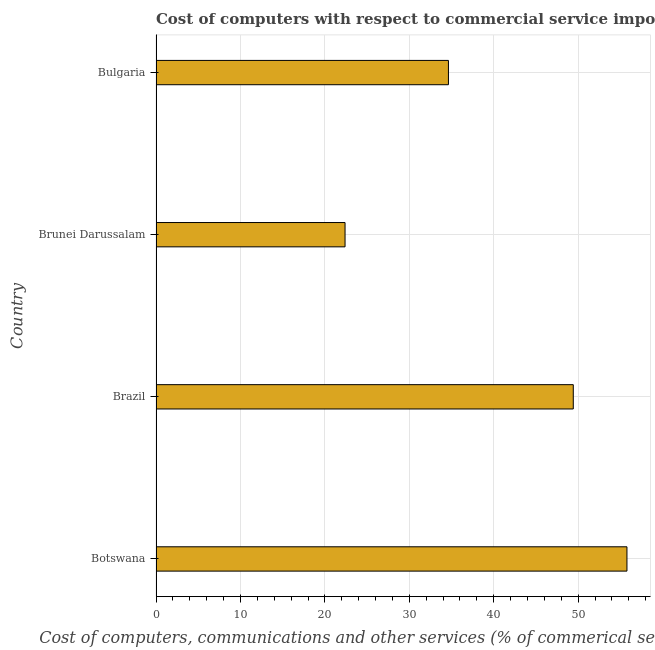Does the graph contain any zero values?
Provide a succinct answer. No. Does the graph contain grids?
Keep it short and to the point. Yes. What is the title of the graph?
Offer a terse response. Cost of computers with respect to commercial service imports of countries in 2009. What is the label or title of the X-axis?
Provide a succinct answer. Cost of computers, communications and other services (% of commerical service exports). What is the cost of communications in Brunei Darussalam?
Your answer should be compact. 22.39. Across all countries, what is the maximum cost of communications?
Keep it short and to the point. 55.78. Across all countries, what is the minimum  computer and other services?
Provide a succinct answer. 22.39. In which country was the cost of communications maximum?
Your response must be concise. Botswana. In which country was the  computer and other services minimum?
Provide a succinct answer. Brunei Darussalam. What is the sum of the cost of communications?
Offer a terse response. 162.22. What is the difference between the cost of communications in Brunei Darussalam and Bulgaria?
Give a very brief answer. -12.25. What is the average  computer and other services per country?
Your answer should be very brief. 40.55. What is the median  computer and other services?
Give a very brief answer. 42.03. What is the ratio of the cost of communications in Botswana to that in Brunei Darussalam?
Keep it short and to the point. 2.49. Is the  computer and other services in Brazil less than that in Bulgaria?
Give a very brief answer. No. Is the difference between the cost of communications in Brazil and Brunei Darussalam greater than the difference between any two countries?
Provide a succinct answer. No. What is the difference between the highest and the second highest cost of communications?
Your response must be concise. 6.36. What is the difference between the highest and the lowest cost of communications?
Your answer should be compact. 33.39. How many bars are there?
Ensure brevity in your answer.  4. What is the difference between two consecutive major ticks on the X-axis?
Make the answer very short. 10. Are the values on the major ticks of X-axis written in scientific E-notation?
Your answer should be compact. No. What is the Cost of computers, communications and other services (% of commerical service exports) in Botswana?
Your answer should be compact. 55.78. What is the Cost of computers, communications and other services (% of commerical service exports) of Brazil?
Offer a terse response. 49.42. What is the Cost of computers, communications and other services (% of commerical service exports) in Brunei Darussalam?
Offer a terse response. 22.39. What is the Cost of computers, communications and other services (% of commerical service exports) of Bulgaria?
Your answer should be very brief. 34.63. What is the difference between the Cost of computers, communications and other services (% of commerical service exports) in Botswana and Brazil?
Provide a succinct answer. 6.36. What is the difference between the Cost of computers, communications and other services (% of commerical service exports) in Botswana and Brunei Darussalam?
Provide a succinct answer. 33.39. What is the difference between the Cost of computers, communications and other services (% of commerical service exports) in Botswana and Bulgaria?
Your answer should be very brief. 21.14. What is the difference between the Cost of computers, communications and other services (% of commerical service exports) in Brazil and Brunei Darussalam?
Make the answer very short. 27.03. What is the difference between the Cost of computers, communications and other services (% of commerical service exports) in Brazil and Bulgaria?
Your response must be concise. 14.79. What is the difference between the Cost of computers, communications and other services (% of commerical service exports) in Brunei Darussalam and Bulgaria?
Your response must be concise. -12.25. What is the ratio of the Cost of computers, communications and other services (% of commerical service exports) in Botswana to that in Brazil?
Your answer should be compact. 1.13. What is the ratio of the Cost of computers, communications and other services (% of commerical service exports) in Botswana to that in Brunei Darussalam?
Provide a short and direct response. 2.49. What is the ratio of the Cost of computers, communications and other services (% of commerical service exports) in Botswana to that in Bulgaria?
Provide a succinct answer. 1.61. What is the ratio of the Cost of computers, communications and other services (% of commerical service exports) in Brazil to that in Brunei Darussalam?
Offer a terse response. 2.21. What is the ratio of the Cost of computers, communications and other services (% of commerical service exports) in Brazil to that in Bulgaria?
Your answer should be compact. 1.43. What is the ratio of the Cost of computers, communications and other services (% of commerical service exports) in Brunei Darussalam to that in Bulgaria?
Keep it short and to the point. 0.65. 